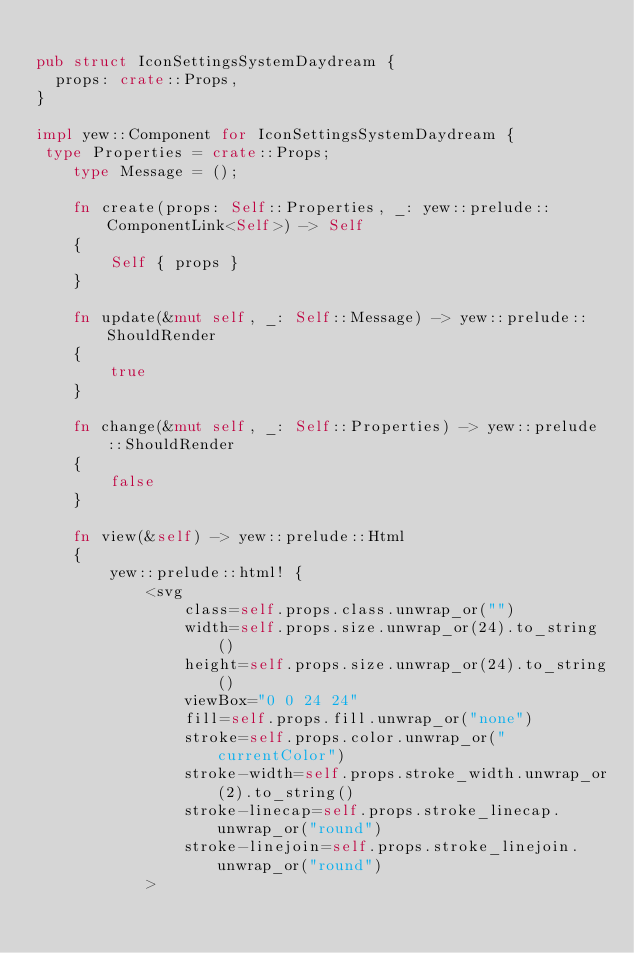Convert code to text. <code><loc_0><loc_0><loc_500><loc_500><_Rust_>
pub struct IconSettingsSystemDaydream {
  props: crate::Props,
}

impl yew::Component for IconSettingsSystemDaydream {
 type Properties = crate::Props;
    type Message = ();

    fn create(props: Self::Properties, _: yew::prelude::ComponentLink<Self>) -> Self
    {
        Self { props }
    }

    fn update(&mut self, _: Self::Message) -> yew::prelude::ShouldRender
    {
        true
    }

    fn change(&mut self, _: Self::Properties) -> yew::prelude::ShouldRender
    {
        false
    }

    fn view(&self) -> yew::prelude::Html
    {
        yew::prelude::html! {
            <svg
                class=self.props.class.unwrap_or("")
                width=self.props.size.unwrap_or(24).to_string()
                height=self.props.size.unwrap_or(24).to_string()
                viewBox="0 0 24 24"
                fill=self.props.fill.unwrap_or("none")
                stroke=self.props.color.unwrap_or("currentColor")
                stroke-width=self.props.stroke_width.unwrap_or(2).to_string()
                stroke-linecap=self.props.stroke_linecap.unwrap_or("round")
                stroke-linejoin=self.props.stroke_linejoin.unwrap_or("round")
            ></code> 